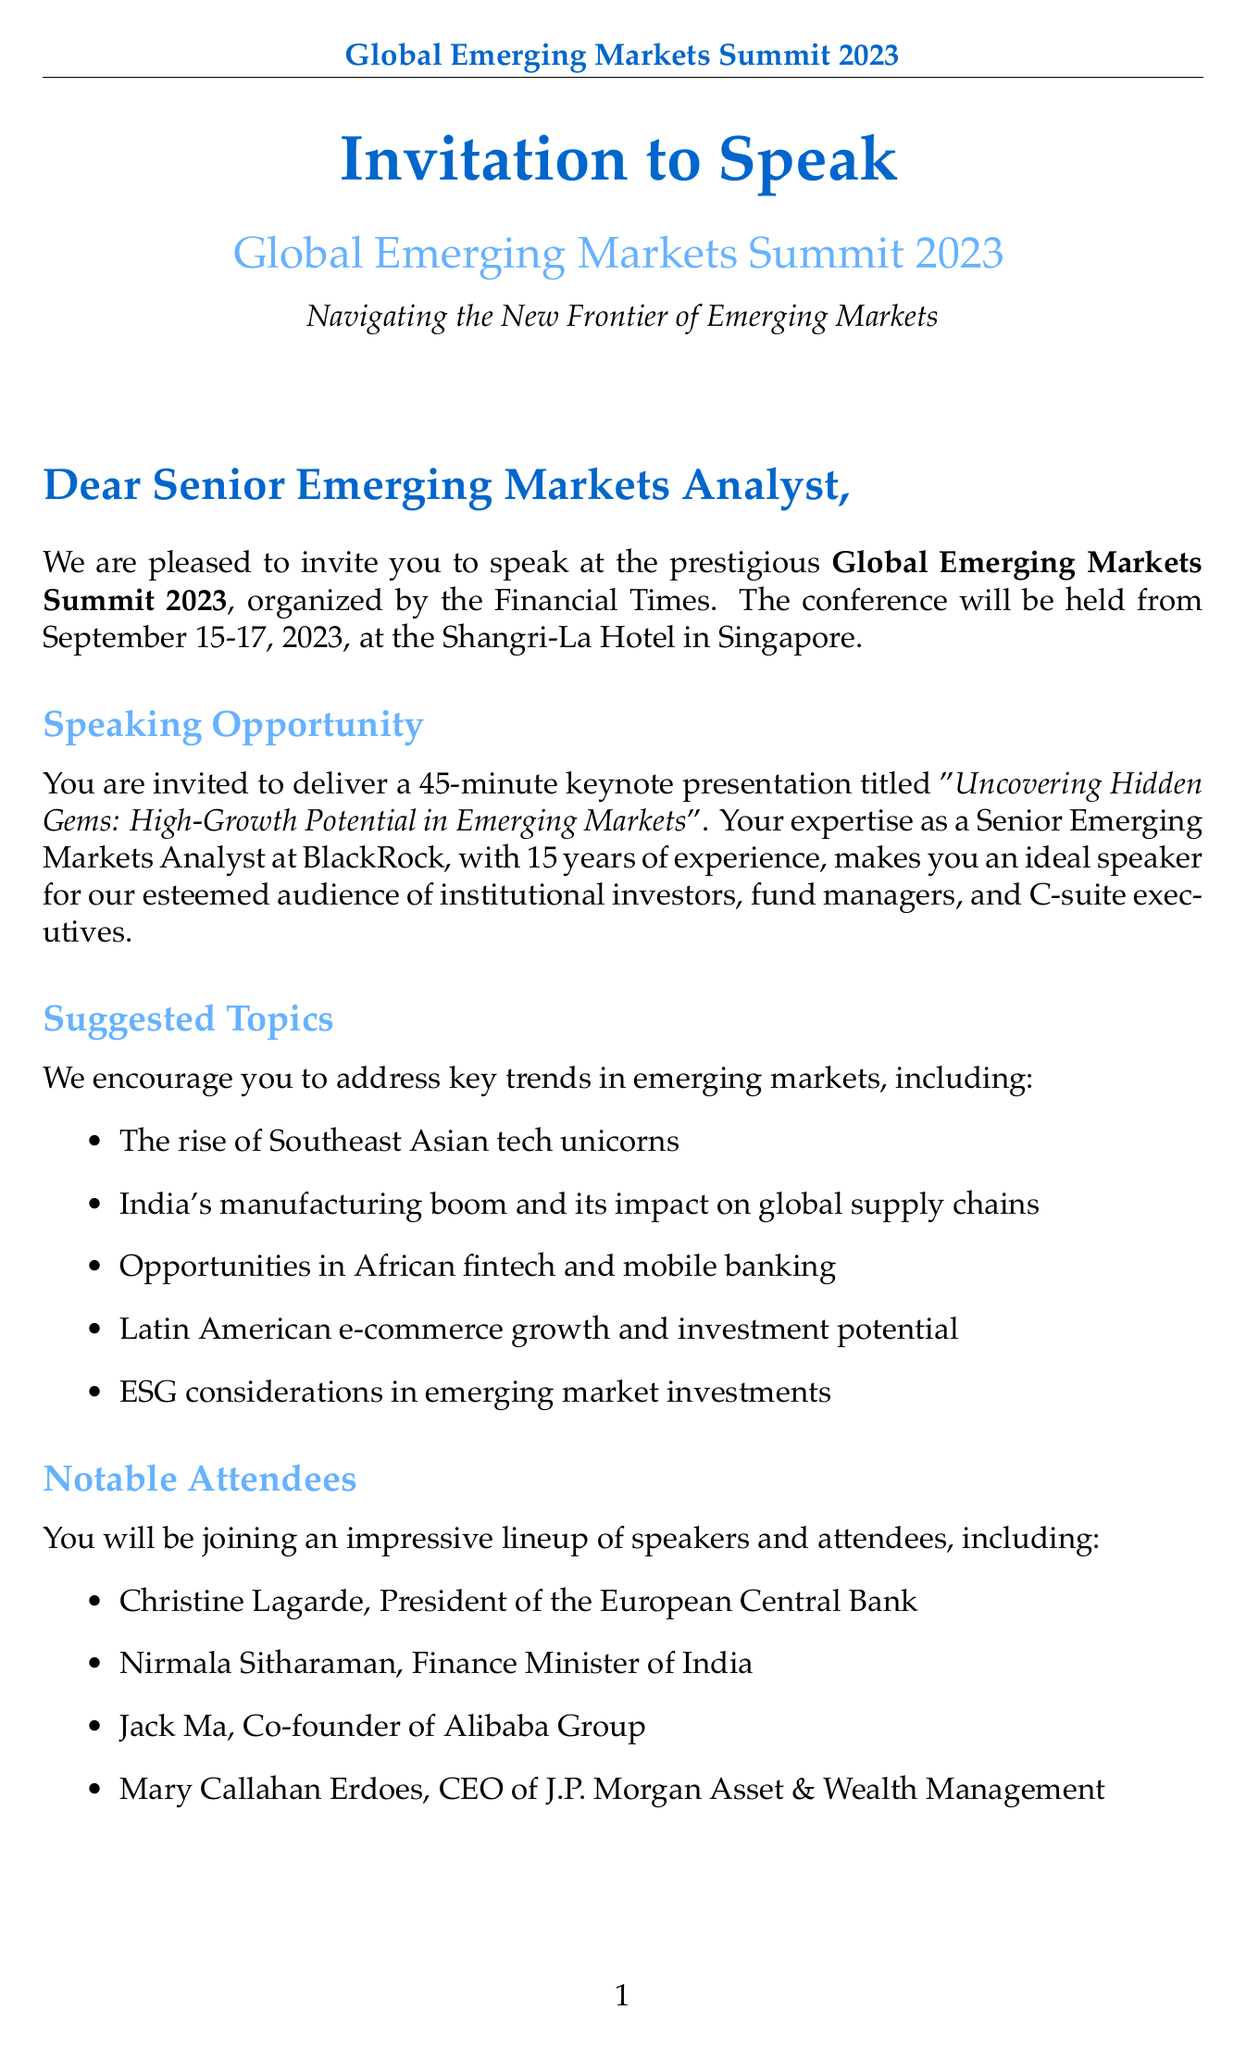What is the name of the conference? The name of the conference is explicitly stated in the document as "Global Emerging Markets Summit 2023."
Answer: Global Emerging Markets Summit 2023 What is the date of the conference? The document clearly mentions that the conference will take place from September 15-17, 2023.
Answer: September 15-17, 2023 What is the title of the keynote presentation? The document specifies the title of the keynote presentation as "Uncovering Hidden Gems: High-Growth Potential in Emerging Markets."
Answer: Uncovering Hidden Gems: High-Growth Potential in Emerging Markets Who are some notable attendees listed in the document? The document provides a list of notable attendees, including Christine Lagarde, Nirmala Sitharaman, Jack Ma, and Mary Callahan Erdoes.
Answer: Christine Lagarde, Nirmala Sitharaman, Jack Ma, Mary Callahan Erdoes How long is the speaking slot for the presentation? The document mentions that the speaking slot is a 45-minute keynote presentation.
Answer: 45 minutes What is one of the suggested topics to address? The document lists several suggested topics, one of which includes "The rise of Southeast Asian tech unicorns."
Answer: The rise of Southeast Asian tech unicorns What benefits do speakers receive according to the document? The document details several benefits for speakers, including complimentary accommodation at the Shangri-La Hotel.
Answer: Complimentary accommodation at the Shangri-La Hotel What organization is hosting the conference? The document indicates that the conference is organized by the Financial Times.
Answer: Financial Times 